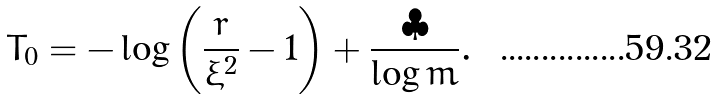<formula> <loc_0><loc_0><loc_500><loc_500>T _ { 0 } = - \log \left ( \frac { r } { \bar { \xi } ^ { 2 } } - 1 \right ) + \frac { \clubsuit } { \log m } .</formula> 